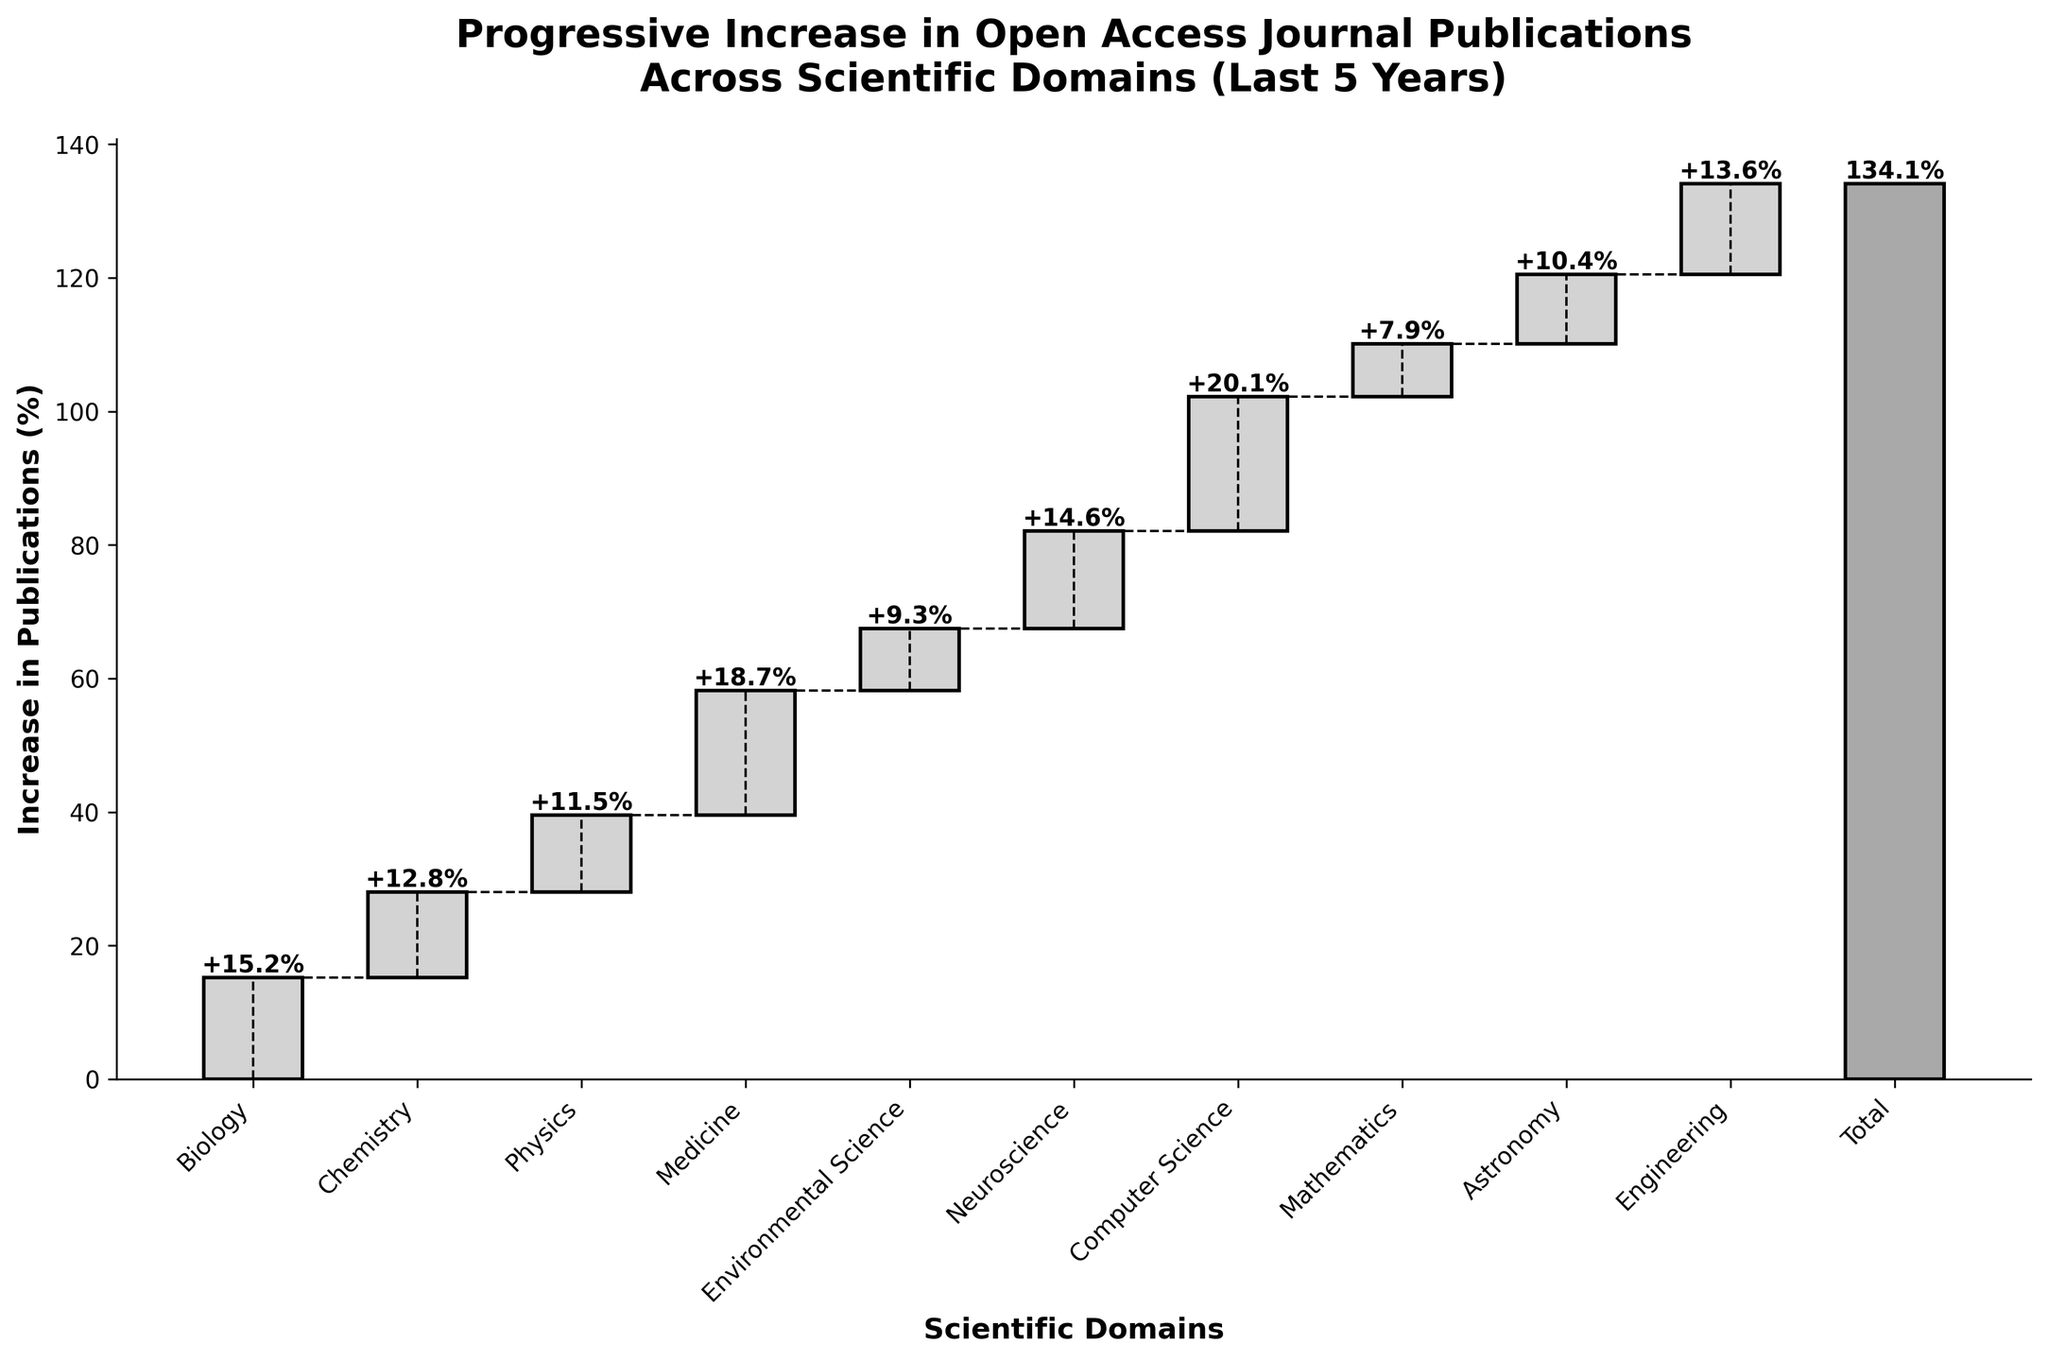What is the title of the plot? The title is located at the top of the figure and helps identify the subject of the visualization by summarizing it in one concise statement.
Answer: Progressive Increase in Open Access Journal Publications Across Scientific Domains (Last 5 Years) How many scientific domains are represented in the plot? The x-axis labels represent different scientific domains. Count the number of these labels excluding the 'Total'.
Answer: 10 Which scientific domain has the highest increase in open access journal publications? Identify the bar with the tallest height or the highest value label among the categories. This bar corresponds to the domain with the highest increase.
Answer: Computer Science What percentage increase do the Biology and Neuroscience domains together contribute to the total? Sum the individual percentage increases of the Biology and Neuroscience domains by identifying their values from the figure.
Answer: 15.2% + 14.6% = 29.8% What is the difference in percentage increase between the Medicine and Mathematics domains? Subtract the percentage increase for Mathematics from that of Medicine by locating their respective values.
Answer: 18.7% - 7.9% = 10.8% Which domain had less than a 10% increase in open access journal publications? Find bars that extend up to less than the 10% mark on the y-axis or identify the values less than 10% from the figure.
Answer: Environmental Science, Mathematics What is the combined percentage increase for Chemistry, Physics, and Engineering? Add the values for Chemistry, Physics, and Engineering by finding their positions on the figure.
Answer: 12.8% + 11.5% + 13.6% = 37.9% What is the approximate cumulative increase in open access publications after adding Medicine's contribution? Find the cumulative value just after Medicine on the plot, either through cumulative sum lines or by summing values progressively.
Answer: 15.2% + 12.8% + 11.5% + 18.7% = 58.2% Does the total increase more than double from Computer Science's contribution alone? Check if the total value exceeds twice the value of the Computer Science increase by comparing the last bar with twice the height/value of the Computer Science bar.
Answer: Yes, 134.1% > 40.2% How does the increase in Astronomy compare to Physics and Chemistry? Compare the values associated with the Astronomy bar to those of Physics and Chemistry by checking the height or the labeled values.
Answer: Astronomy (10.4%) is less than Physics (11.5%) and Chemistry (12.8%) 